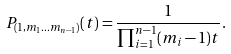<formula> <loc_0><loc_0><loc_500><loc_500>P _ { ( 1 , m _ { 1 } \dots m _ { n - 1 } ) } ( t ) = \frac { 1 } { \prod _ { i = 1 } ^ { n - 1 } ( m _ { i } - 1 ) t } .</formula> 